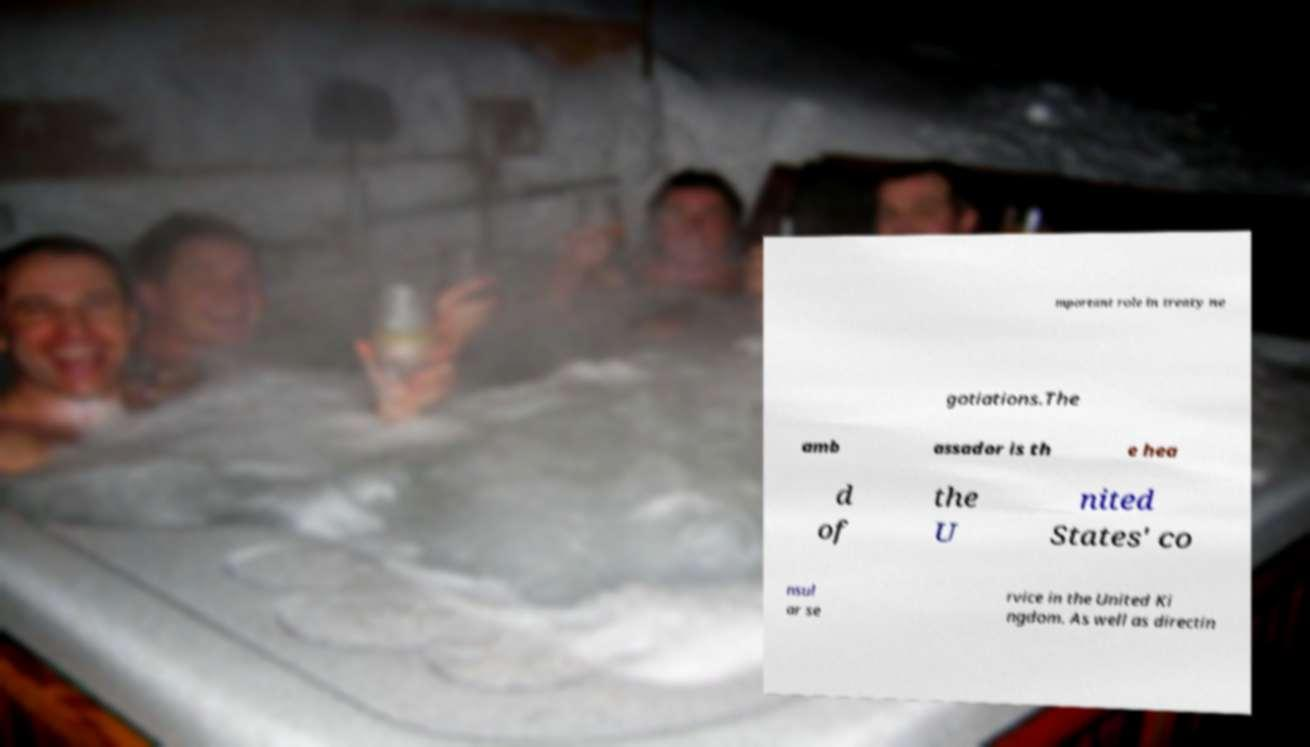Can you accurately transcribe the text from the provided image for me? mportant role in treaty ne gotiations.The amb assador is th e hea d of the U nited States' co nsul ar se rvice in the United Ki ngdom. As well as directin 